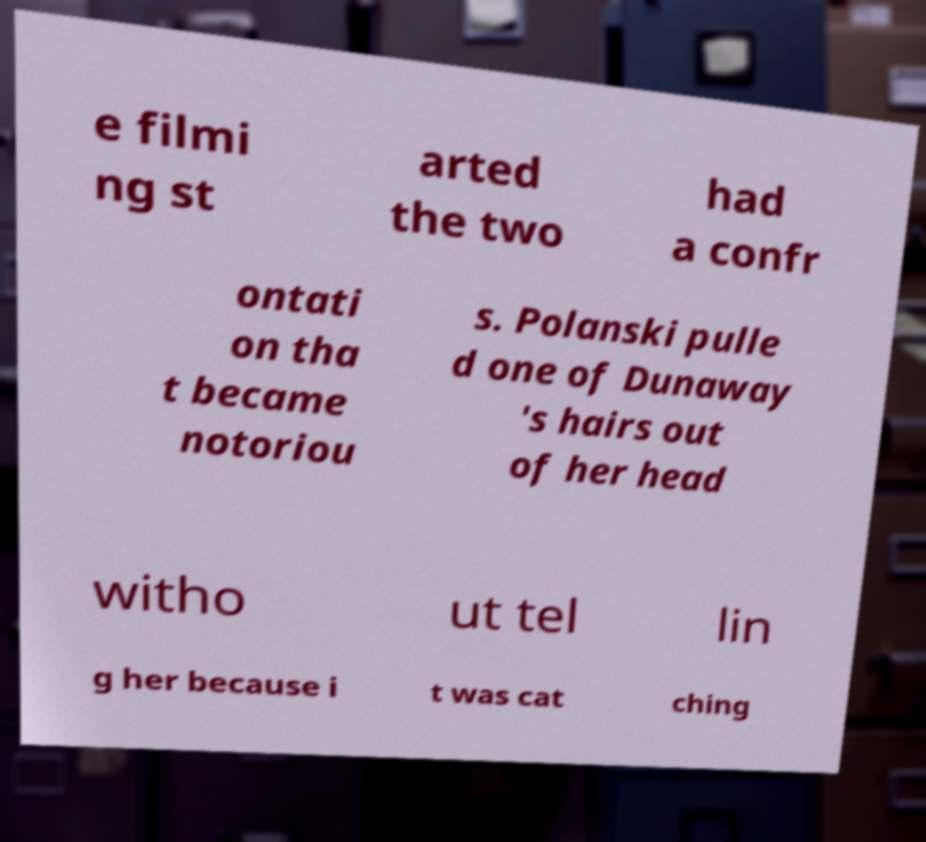Could you assist in decoding the text presented in this image and type it out clearly? e filmi ng st arted the two had a confr ontati on tha t became notoriou s. Polanski pulle d one of Dunaway 's hairs out of her head witho ut tel lin g her because i t was cat ching 